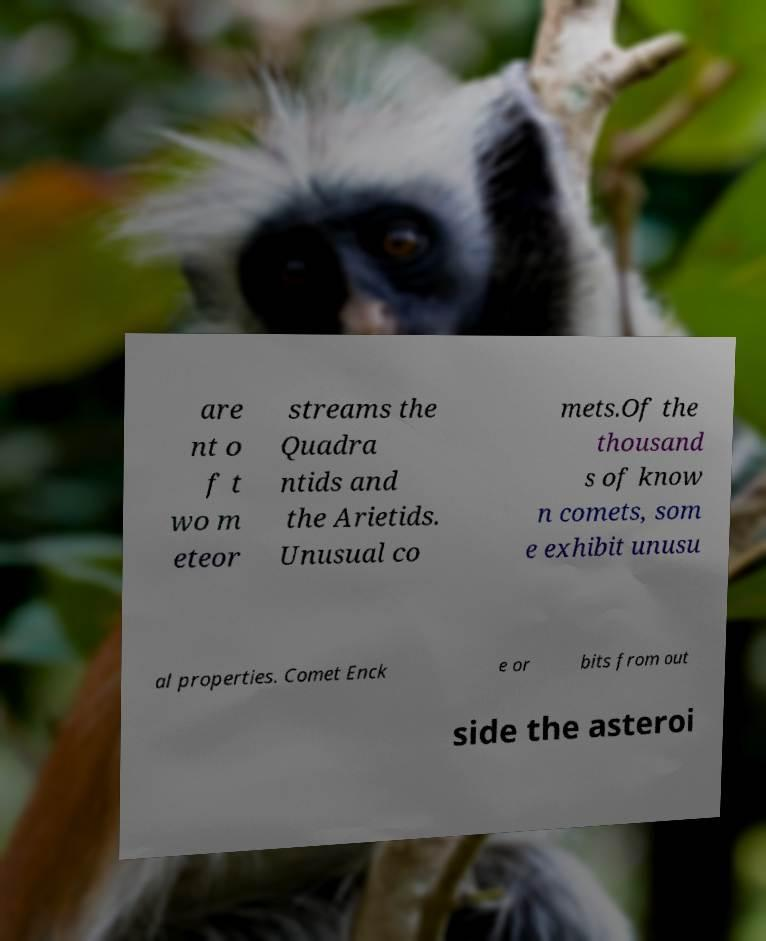Please identify and transcribe the text found in this image. are nt o f t wo m eteor streams the Quadra ntids and the Arietids. Unusual co mets.Of the thousand s of know n comets, som e exhibit unusu al properties. Comet Enck e or bits from out side the asteroi 